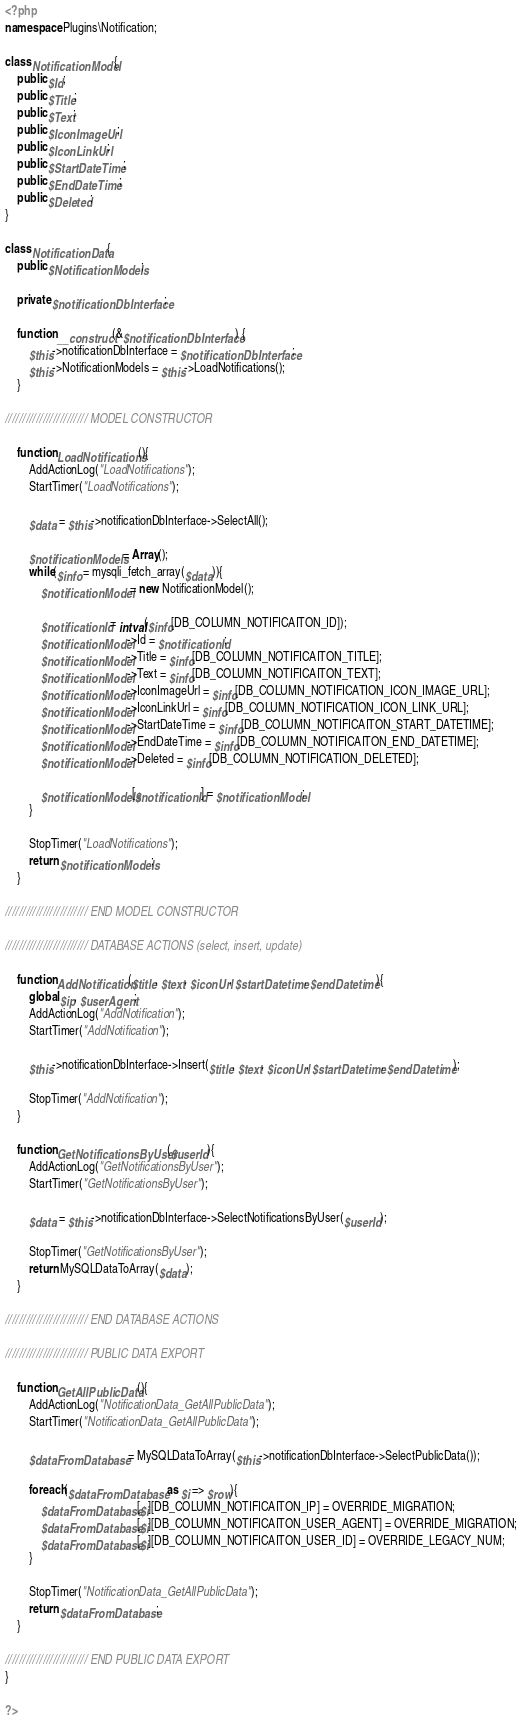<code> <loc_0><loc_0><loc_500><loc_500><_PHP_><?php
namespace Plugins\Notification;

class NotificationModel{
	public $Id;
	public $Title;
	public $Text;
	public $IconImageUrl;
	public $IconLinkUrl;
	public $StartDateTime;
	public $EndDateTime;
	public $Deleted;
}

class NotificationData{
    public $NotificationModels;

    private $notificationDbInterface;

    function __construct(&$notificationDbInterface) {
        $this->notificationDbInterface = $notificationDbInterface;
        $this->NotificationModels = $this->LoadNotifications();
    }

//////////////////////// MODEL CONSTRUCTOR

    function LoadNotifications(){
        AddActionLog("LoadNotifications");
        StartTimer("LoadNotifications");

        $data = $this->notificationDbInterface->SelectAll();

        $notificationModels = Array();
        while($info = mysqli_fetch_array($data)){
            $notificationModel = new NotificationModel();

            $notificationId = intval($info[DB_COLUMN_NOTIFICAITON_ID]);
            $notificationModel->Id = $notificationId;
            $notificationModel->Title = $info[DB_COLUMN_NOTIFICAITON_TITLE];
            $notificationModel->Text = $info[DB_COLUMN_NOTIFICAITON_TEXT];
            $notificationModel->IconImageUrl = $info[DB_COLUMN_NOTIFICATION_ICON_IMAGE_URL];
            $notificationModel->IconLinkUrl = $info[DB_COLUMN_NOTIFICATION_ICON_LINK_URL];
            $notificationModel->StartDateTime = $info[DB_COLUMN_NOTIFICAITON_START_DATETIME];
            $notificationModel->EndDateTime = $info[DB_COLUMN_NOTIFICAITON_END_DATETIME];
            $notificationModel->Deleted = $info[DB_COLUMN_NOTIFICATION_DELETED];

            $notificationModels[$notificationId] = $notificationModel;
        }

        StopTimer("LoadNotifications");
        return $notificationModels;
    }

//////////////////////// END MODEL CONSTRUCTOR
    
//////////////////////// DATABASE ACTIONS (select, insert, update)

    function AddNotification($title, $text, $iconUrl, $startDatetime, $endDatetime){
        global $ip, $userAgent;
        AddActionLog("AddNotification");
        StartTimer("AddNotification");

        $this->notificationDbInterface->Insert($title, $text, $iconUrl, $startDatetime, $endDatetime);

        StopTimer("AddNotification");
    }
    
    function GetNotificationsByUser($userId){
        AddActionLog("GetNotificationsByUser");
        StartTimer("GetNotificationsByUser");
    
        $data = $this->notificationDbInterface->SelectNotificationsByUser($userId);
    
        StopTimer("GetNotificationsByUser");
        return MySQLDataToArray($data);
    }

//////////////////////// END DATABASE ACTIONS

//////////////////////// PUBLIC DATA EXPORT

    function GetAllPublicData(){
        AddActionLog("NotificationData_GetAllPublicData");
        StartTimer("NotificationData_GetAllPublicData");
        
        $dataFromDatabase = MySQLDataToArray($this->notificationDbInterface->SelectPublicData());

        foreach($dataFromDatabase as $i => $row){
            $dataFromDatabase[$i][DB_COLUMN_NOTIFICAITON_IP] = OVERRIDE_MIGRATION;
            $dataFromDatabase[$i][DB_COLUMN_NOTIFICAITON_USER_AGENT] = OVERRIDE_MIGRATION;
            $dataFromDatabase[$i][DB_COLUMN_NOTIFICAITON_USER_ID] = OVERRIDE_LEGACY_NUM;
        }

        StopTimer("NotificationData_GetAllPublicData");
        return $dataFromDatabase;
    }

//////////////////////// END PUBLIC DATA EXPORT
}

?></code> 